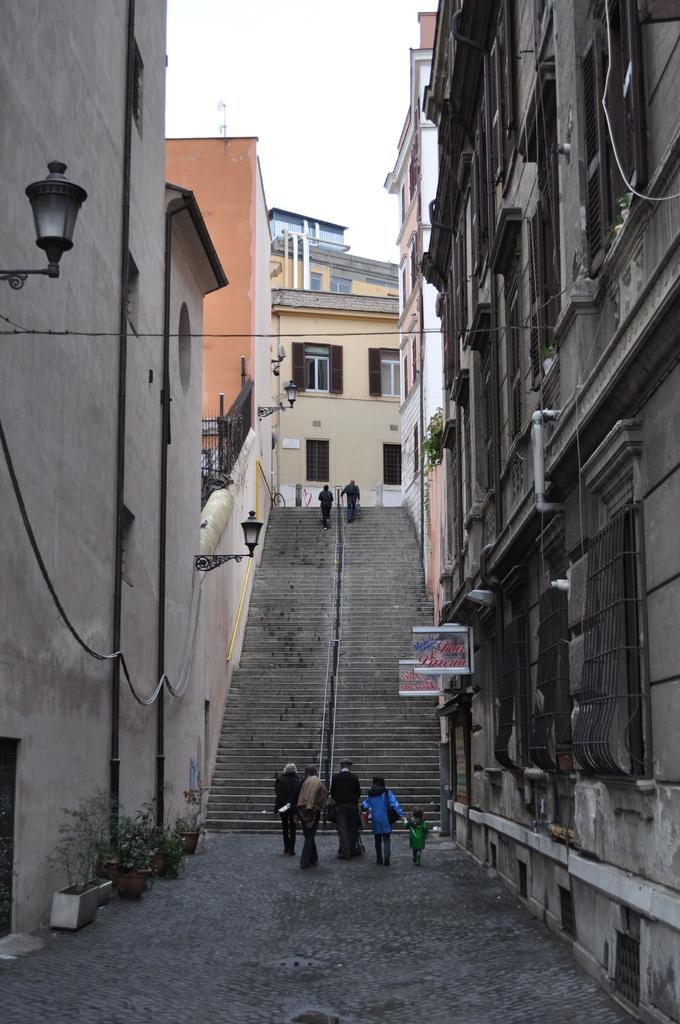How many people are in the image? There is a group of people in the image. What are the people in the image doing? The people are walking. What can be seen in the background of the image? There are hoardings, lights, plants, buildings, and pipes in the image. What type of berry can be seen growing on the pipes in the image? There are no berries present in the image, and the pipes are not associated with any plant growth. 